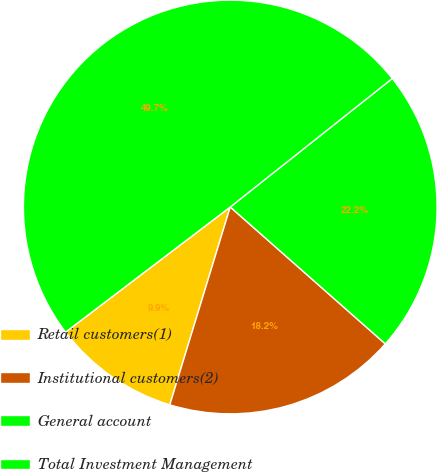Convert chart. <chart><loc_0><loc_0><loc_500><loc_500><pie_chart><fcel>Retail customers(1)<fcel>Institutional customers(2)<fcel>General account<fcel>Total Investment Management<nl><fcel>9.94%<fcel>18.21%<fcel>22.18%<fcel>49.67%<nl></chart> 